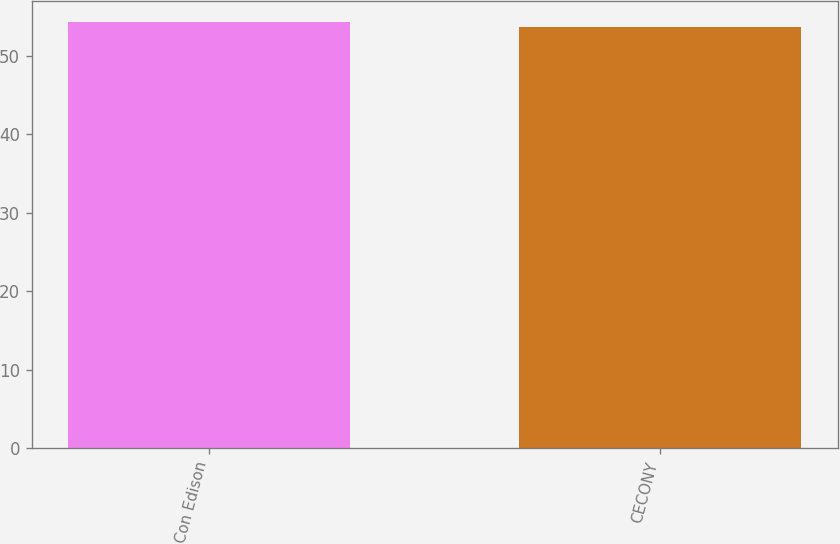<chart> <loc_0><loc_0><loc_500><loc_500><bar_chart><fcel>Con Edison<fcel>CECONY<nl><fcel>54.3<fcel>53.7<nl></chart> 